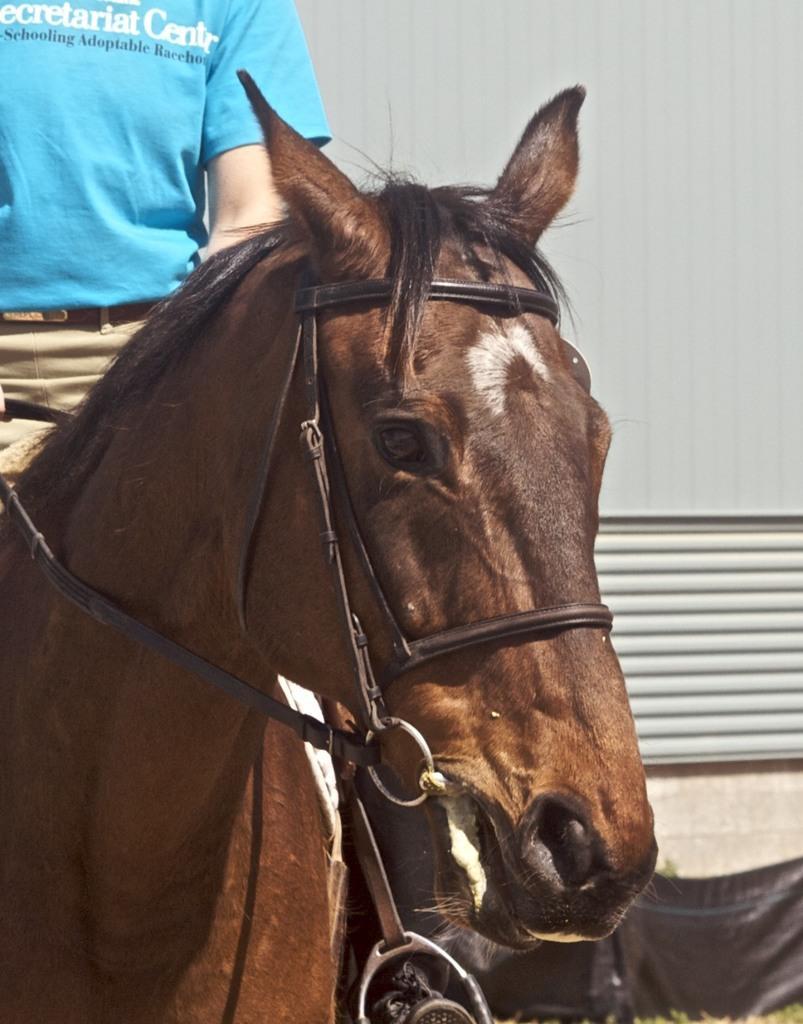In one or two sentences, can you explain what this image depicts? On the left side of this image there is a person wearing a blue color t-shirt and riding a horse. On the right side there is a wall. At the bottom there is a black color object. 